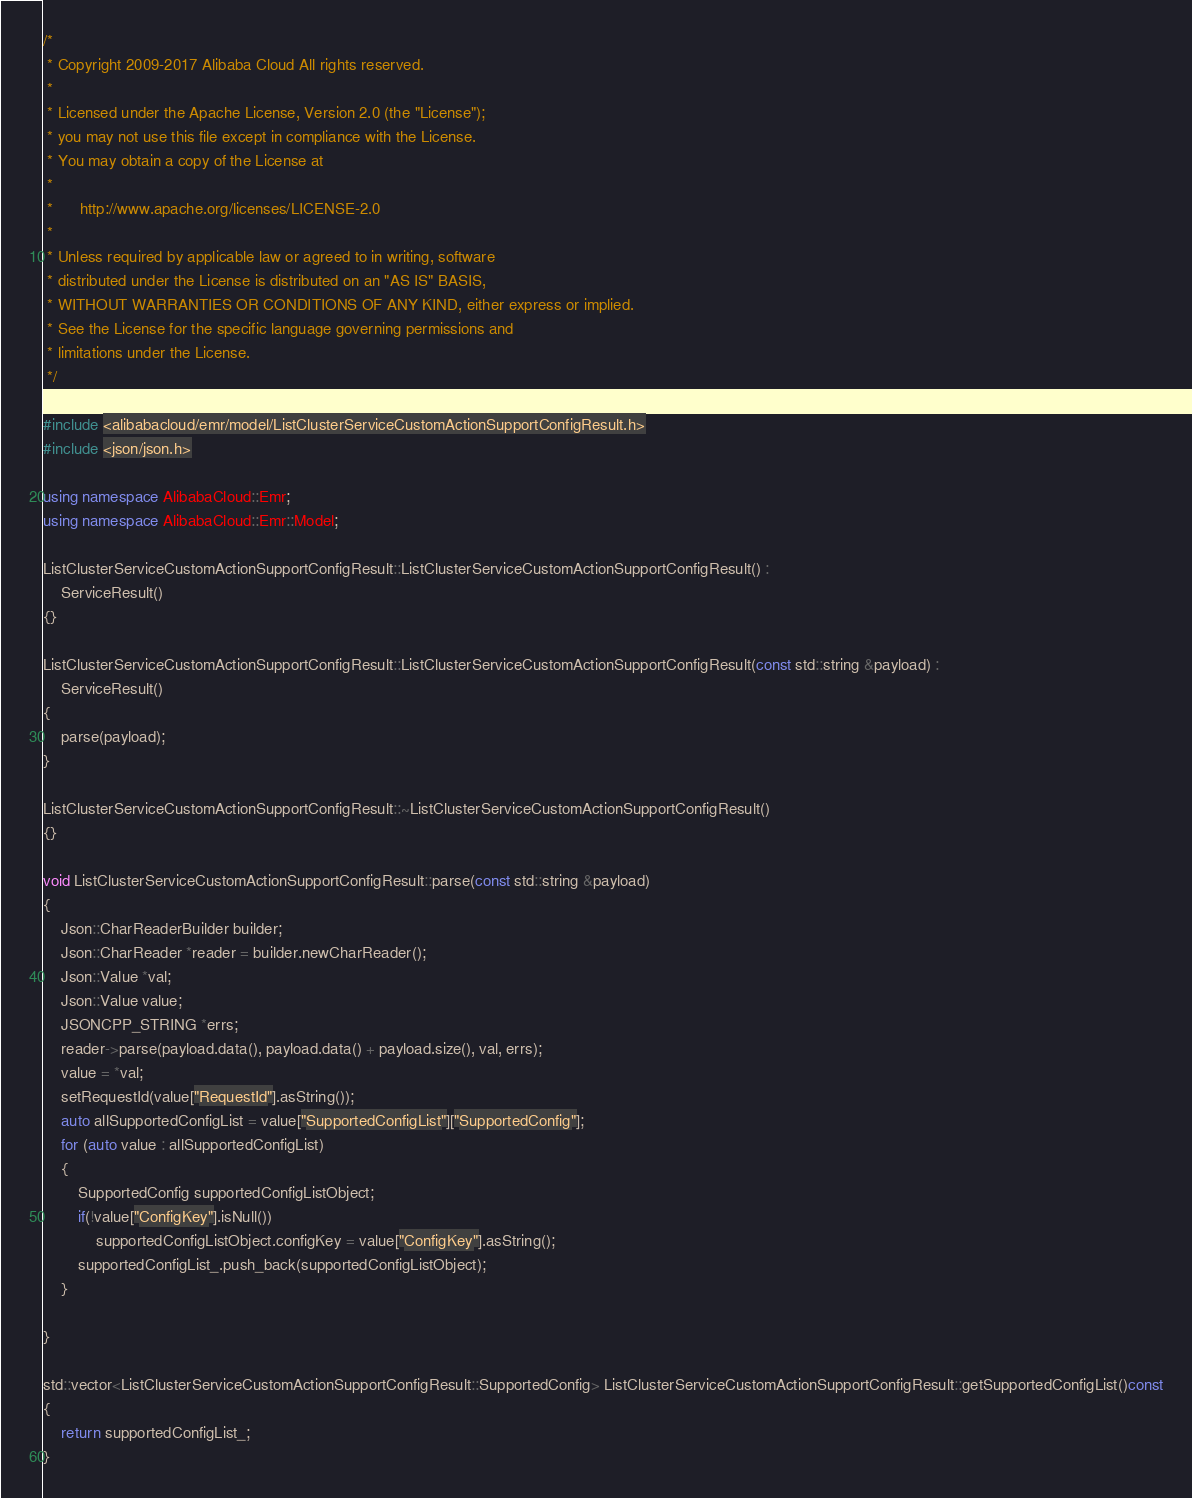Convert code to text. <code><loc_0><loc_0><loc_500><loc_500><_C++_>/*
 * Copyright 2009-2017 Alibaba Cloud All rights reserved.
 * 
 * Licensed under the Apache License, Version 2.0 (the "License");
 * you may not use this file except in compliance with the License.
 * You may obtain a copy of the License at
 * 
 *      http://www.apache.org/licenses/LICENSE-2.0
 * 
 * Unless required by applicable law or agreed to in writing, software
 * distributed under the License is distributed on an "AS IS" BASIS,
 * WITHOUT WARRANTIES OR CONDITIONS OF ANY KIND, either express or implied.
 * See the License for the specific language governing permissions and
 * limitations under the License.
 */

#include <alibabacloud/emr/model/ListClusterServiceCustomActionSupportConfigResult.h>
#include <json/json.h>

using namespace AlibabaCloud::Emr;
using namespace AlibabaCloud::Emr::Model;

ListClusterServiceCustomActionSupportConfigResult::ListClusterServiceCustomActionSupportConfigResult() :
	ServiceResult()
{}

ListClusterServiceCustomActionSupportConfigResult::ListClusterServiceCustomActionSupportConfigResult(const std::string &payload) :
	ServiceResult()
{
	parse(payload);
}

ListClusterServiceCustomActionSupportConfigResult::~ListClusterServiceCustomActionSupportConfigResult()
{}

void ListClusterServiceCustomActionSupportConfigResult::parse(const std::string &payload)
{
	Json::CharReaderBuilder builder;
	Json::CharReader *reader = builder.newCharReader();
	Json::Value *val;
	Json::Value value;
	JSONCPP_STRING *errs;
	reader->parse(payload.data(), payload.data() + payload.size(), val, errs);
	value = *val;
	setRequestId(value["RequestId"].asString());
	auto allSupportedConfigList = value["SupportedConfigList"]["SupportedConfig"];
	for (auto value : allSupportedConfigList)
	{
		SupportedConfig supportedConfigListObject;
		if(!value["ConfigKey"].isNull())
			supportedConfigListObject.configKey = value["ConfigKey"].asString();
		supportedConfigList_.push_back(supportedConfigListObject);
	}

}

std::vector<ListClusterServiceCustomActionSupportConfigResult::SupportedConfig> ListClusterServiceCustomActionSupportConfigResult::getSupportedConfigList()const
{
	return supportedConfigList_;
}

</code> 